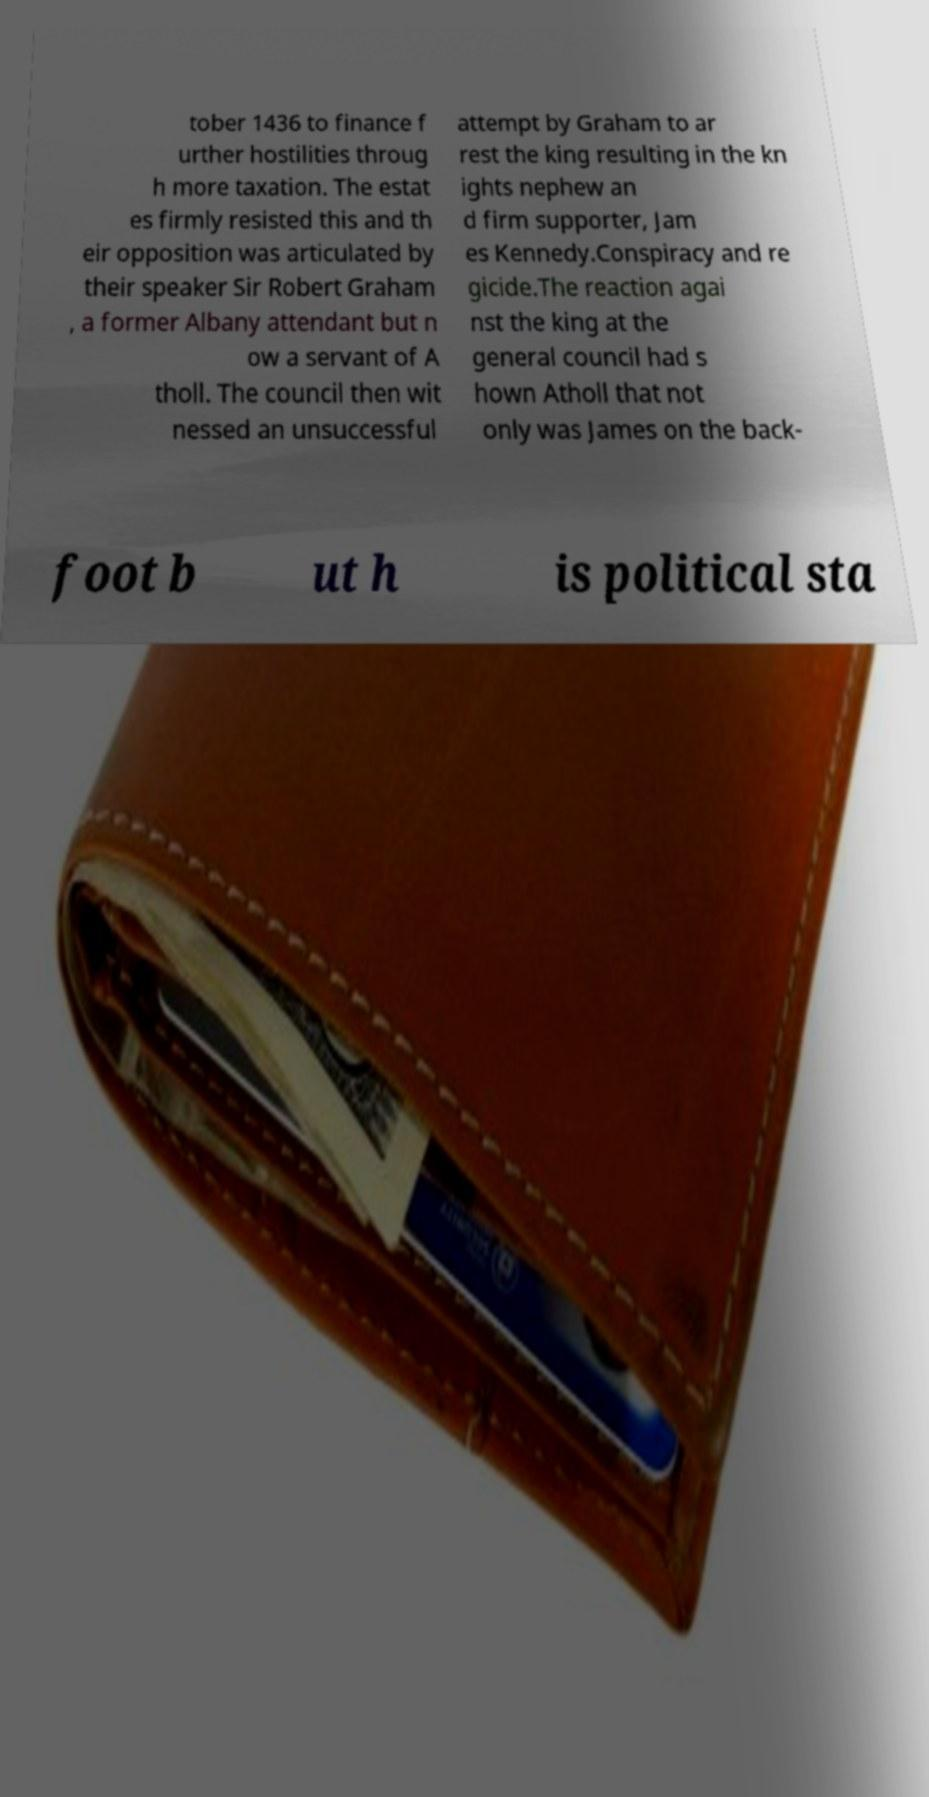Please read and relay the text visible in this image. What does it say? tober 1436 to finance f urther hostilities throug h more taxation. The estat es firmly resisted this and th eir opposition was articulated by their speaker Sir Robert Graham , a former Albany attendant but n ow a servant of A tholl. The council then wit nessed an unsuccessful attempt by Graham to ar rest the king resulting in the kn ights nephew an d firm supporter, Jam es Kennedy.Conspiracy and re gicide.The reaction agai nst the king at the general council had s hown Atholl that not only was James on the back- foot b ut h is political sta 